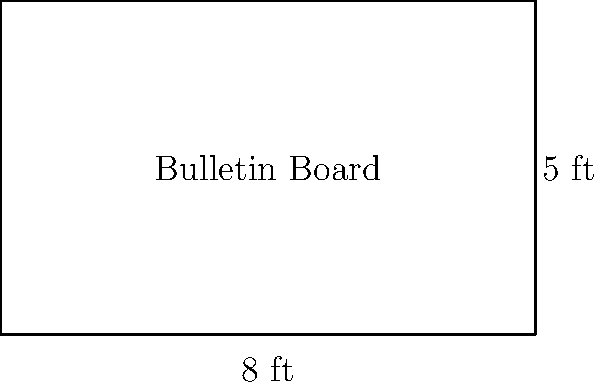As the language school director, you need to purchase a new bulletin board for displaying student achievements. The rectangular board measures 8 feet in width and 5 feet in height. Calculate the area of the bulletin board in square feet. To find the area of a rectangular bulletin board, we need to multiply its width by its height.

Given:
- Width = 8 feet
- Height = 5 feet

Step 1: Apply the formula for the area of a rectangle
Area = Width × Height

Step 2: Substitute the known values
Area = 8 ft × 5 ft

Step 3: Perform the multiplication
Area = 40 sq ft

Therefore, the area of the bulletin board is 40 square feet.
Answer: $40 \text{ sq ft}$ 